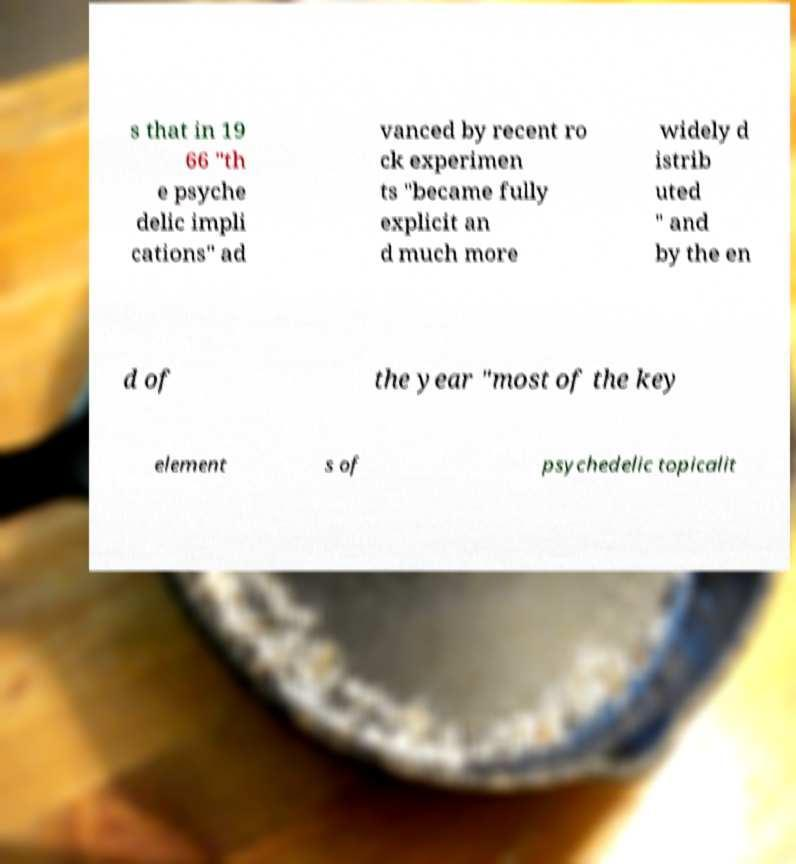Could you extract and type out the text from this image? s that in 19 66 "th e psyche delic impli cations" ad vanced by recent ro ck experimen ts "became fully explicit an d much more widely d istrib uted " and by the en d of the year "most of the key element s of psychedelic topicalit 